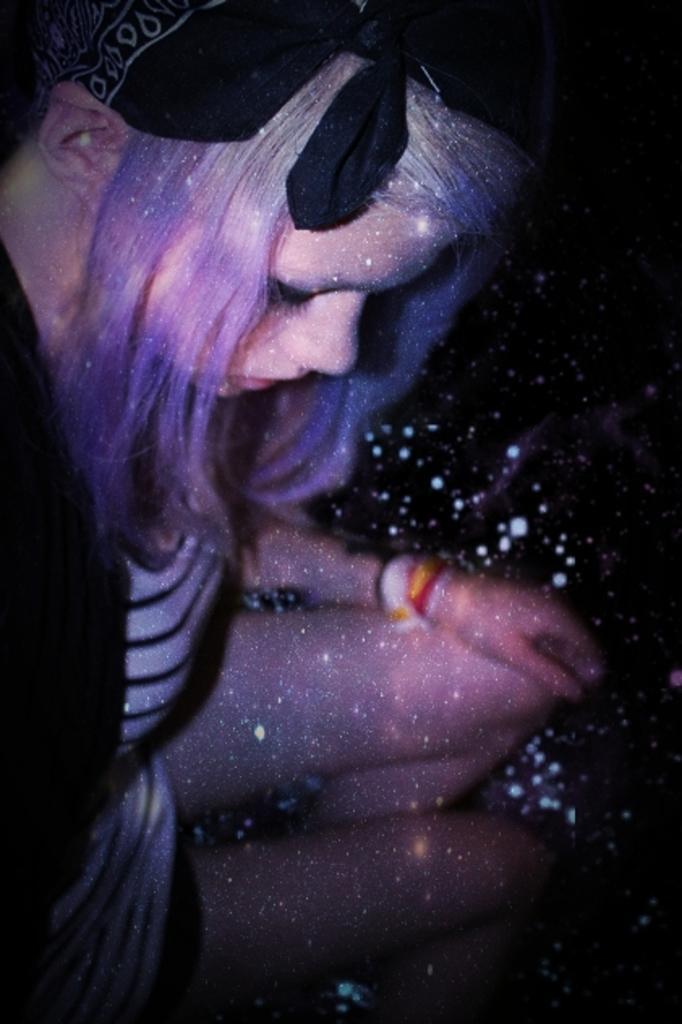In one or two sentences, can you explain what this image depicts? In this image I can see a person sitting. She is wearing white and black color dress. I can see a different shades. Background is in black color. 